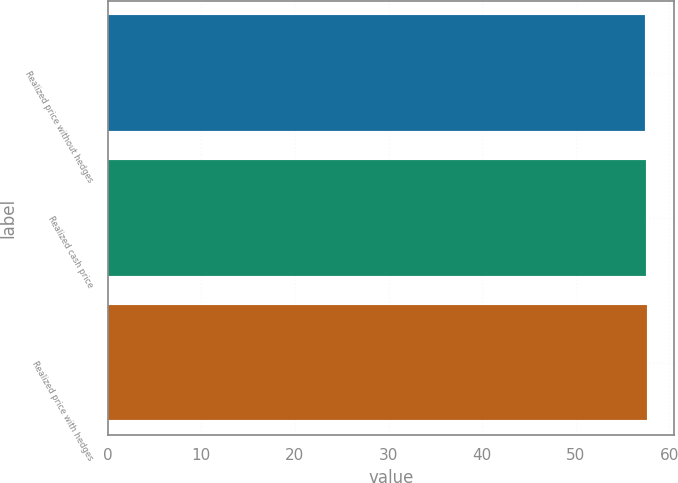<chart> <loc_0><loc_0><loc_500><loc_500><bar_chart><fcel>Realized price without hedges<fcel>Realized cash price<fcel>Realized price with hedges<nl><fcel>57.39<fcel>57.49<fcel>57.59<nl></chart> 